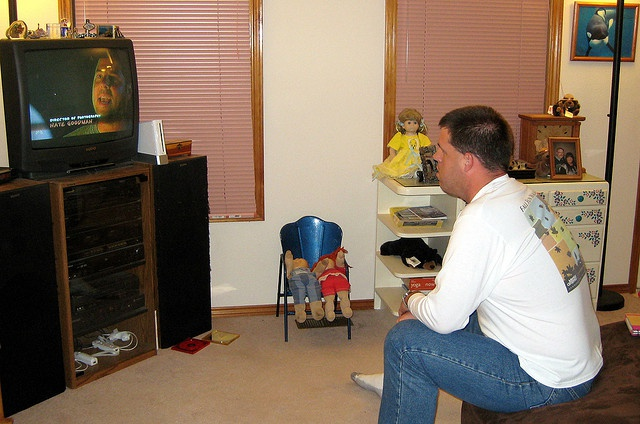Describe the objects in this image and their specific colors. I can see people in khaki, white, blue, black, and gray tones, tv in khaki, black, olive, and maroon tones, couch in khaki, black, and maroon tones, people in khaki, black, olive, brown, and maroon tones, and chair in khaki, black, navy, and blue tones in this image. 